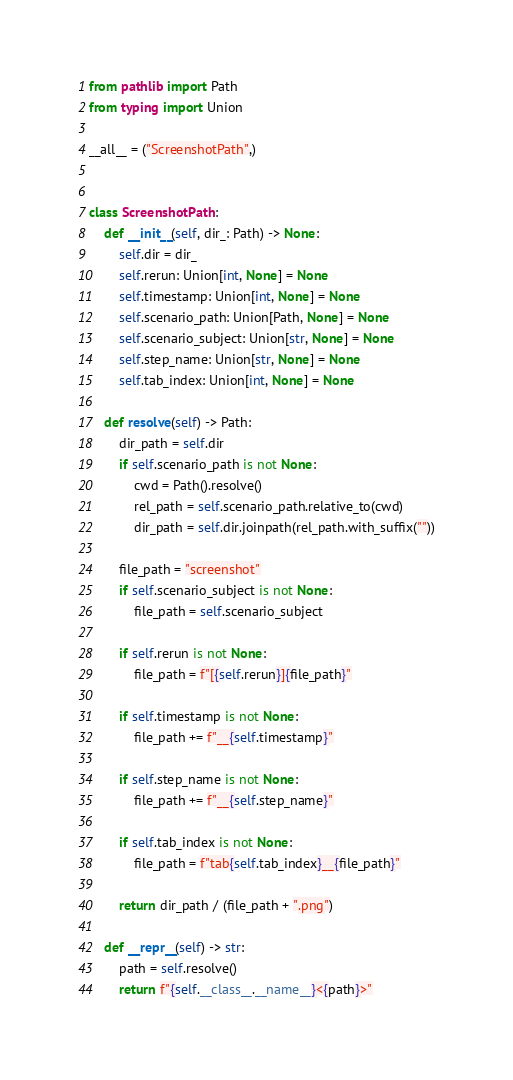<code> <loc_0><loc_0><loc_500><loc_500><_Python_>from pathlib import Path
from typing import Union

__all__ = ("ScreenshotPath",)


class ScreenshotPath:
    def __init__(self, dir_: Path) -> None:
        self.dir = dir_
        self.rerun: Union[int, None] = None
        self.timestamp: Union[int, None] = None
        self.scenario_path: Union[Path, None] = None
        self.scenario_subject: Union[str, None] = None
        self.step_name: Union[str, None] = None
        self.tab_index: Union[int, None] = None

    def resolve(self) -> Path:
        dir_path = self.dir
        if self.scenario_path is not None:
            cwd = Path().resolve()
            rel_path = self.scenario_path.relative_to(cwd)
            dir_path = self.dir.joinpath(rel_path.with_suffix(""))

        file_path = "screenshot"
        if self.scenario_subject is not None:
            file_path = self.scenario_subject

        if self.rerun is not None:
            file_path = f"[{self.rerun}]{file_path}"

        if self.timestamp is not None:
            file_path += f"__{self.timestamp}"

        if self.step_name is not None:
            file_path += f"__{self.step_name}"

        if self.tab_index is not None:
            file_path = f"tab{self.tab_index}__{file_path}"

        return dir_path / (file_path + ".png")

    def __repr__(self) -> str:
        path = self.resolve()
        return f"{self.__class__.__name__}<{path}>"
</code> 